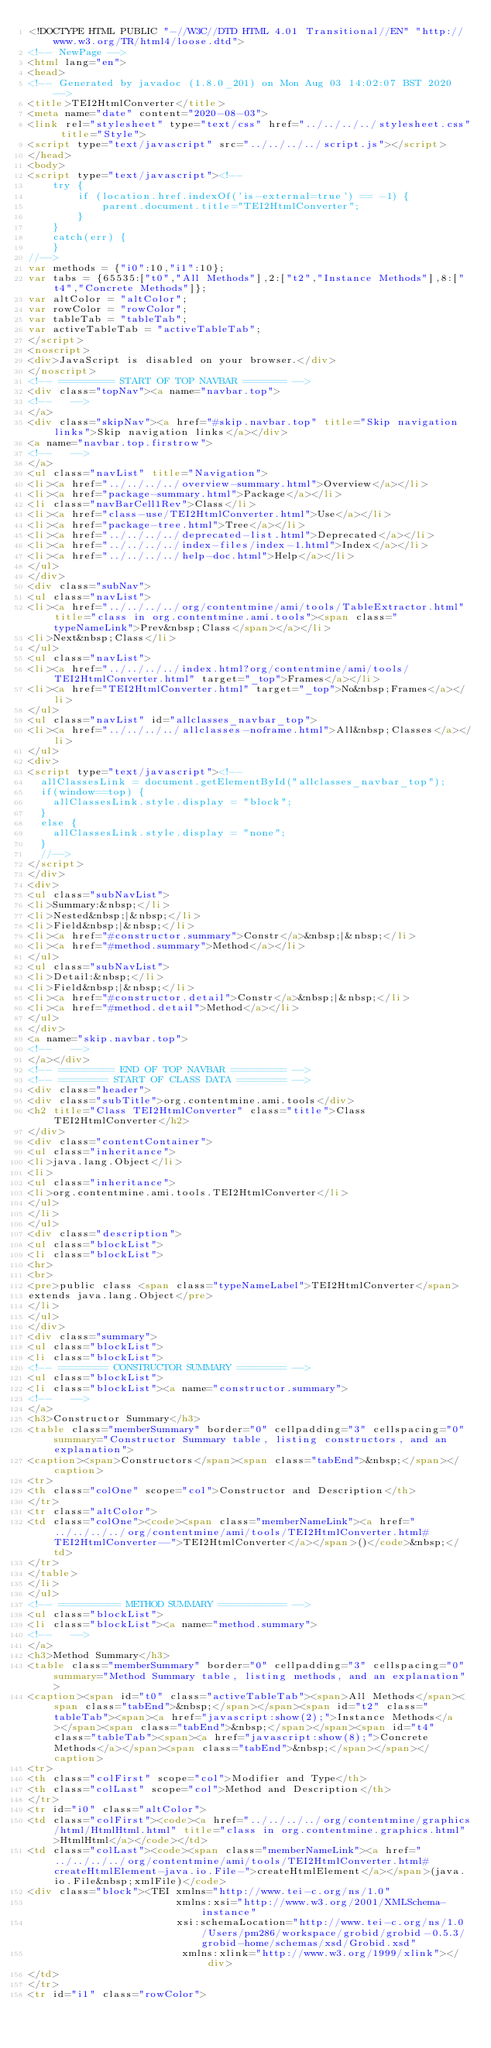<code> <loc_0><loc_0><loc_500><loc_500><_HTML_><!DOCTYPE HTML PUBLIC "-//W3C//DTD HTML 4.01 Transitional//EN" "http://www.w3.org/TR/html4/loose.dtd">
<!-- NewPage -->
<html lang="en">
<head>
<!-- Generated by javadoc (1.8.0_201) on Mon Aug 03 14:02:07 BST 2020 -->
<title>TEI2HtmlConverter</title>
<meta name="date" content="2020-08-03">
<link rel="stylesheet" type="text/css" href="../../../../stylesheet.css" title="Style">
<script type="text/javascript" src="../../../../script.js"></script>
</head>
<body>
<script type="text/javascript"><!--
    try {
        if (location.href.indexOf('is-external=true') == -1) {
            parent.document.title="TEI2HtmlConverter";
        }
    }
    catch(err) {
    }
//-->
var methods = {"i0":10,"i1":10};
var tabs = {65535:["t0","All Methods"],2:["t2","Instance Methods"],8:["t4","Concrete Methods"]};
var altColor = "altColor";
var rowColor = "rowColor";
var tableTab = "tableTab";
var activeTableTab = "activeTableTab";
</script>
<noscript>
<div>JavaScript is disabled on your browser.</div>
</noscript>
<!-- ========= START OF TOP NAVBAR ======= -->
<div class="topNav"><a name="navbar.top">
<!--   -->
</a>
<div class="skipNav"><a href="#skip.navbar.top" title="Skip navigation links">Skip navigation links</a></div>
<a name="navbar.top.firstrow">
<!--   -->
</a>
<ul class="navList" title="Navigation">
<li><a href="../../../../overview-summary.html">Overview</a></li>
<li><a href="package-summary.html">Package</a></li>
<li class="navBarCell1Rev">Class</li>
<li><a href="class-use/TEI2HtmlConverter.html">Use</a></li>
<li><a href="package-tree.html">Tree</a></li>
<li><a href="../../../../deprecated-list.html">Deprecated</a></li>
<li><a href="../../../../index-files/index-1.html">Index</a></li>
<li><a href="../../../../help-doc.html">Help</a></li>
</ul>
</div>
<div class="subNav">
<ul class="navList">
<li><a href="../../../../org/contentmine/ami/tools/TableExtractor.html" title="class in org.contentmine.ami.tools"><span class="typeNameLink">Prev&nbsp;Class</span></a></li>
<li>Next&nbsp;Class</li>
</ul>
<ul class="navList">
<li><a href="../../../../index.html?org/contentmine/ami/tools/TEI2HtmlConverter.html" target="_top">Frames</a></li>
<li><a href="TEI2HtmlConverter.html" target="_top">No&nbsp;Frames</a></li>
</ul>
<ul class="navList" id="allclasses_navbar_top">
<li><a href="../../../../allclasses-noframe.html">All&nbsp;Classes</a></li>
</ul>
<div>
<script type="text/javascript"><!--
  allClassesLink = document.getElementById("allclasses_navbar_top");
  if(window==top) {
    allClassesLink.style.display = "block";
  }
  else {
    allClassesLink.style.display = "none";
  }
  //-->
</script>
</div>
<div>
<ul class="subNavList">
<li>Summary:&nbsp;</li>
<li>Nested&nbsp;|&nbsp;</li>
<li>Field&nbsp;|&nbsp;</li>
<li><a href="#constructor.summary">Constr</a>&nbsp;|&nbsp;</li>
<li><a href="#method.summary">Method</a></li>
</ul>
<ul class="subNavList">
<li>Detail:&nbsp;</li>
<li>Field&nbsp;|&nbsp;</li>
<li><a href="#constructor.detail">Constr</a>&nbsp;|&nbsp;</li>
<li><a href="#method.detail">Method</a></li>
</ul>
</div>
<a name="skip.navbar.top">
<!--   -->
</a></div>
<!-- ========= END OF TOP NAVBAR ========= -->
<!-- ======== START OF CLASS DATA ======== -->
<div class="header">
<div class="subTitle">org.contentmine.ami.tools</div>
<h2 title="Class TEI2HtmlConverter" class="title">Class TEI2HtmlConverter</h2>
</div>
<div class="contentContainer">
<ul class="inheritance">
<li>java.lang.Object</li>
<li>
<ul class="inheritance">
<li>org.contentmine.ami.tools.TEI2HtmlConverter</li>
</ul>
</li>
</ul>
<div class="description">
<ul class="blockList">
<li class="blockList">
<hr>
<br>
<pre>public class <span class="typeNameLabel">TEI2HtmlConverter</span>
extends java.lang.Object</pre>
</li>
</ul>
</div>
<div class="summary">
<ul class="blockList">
<li class="blockList">
<!-- ======== CONSTRUCTOR SUMMARY ======== -->
<ul class="blockList">
<li class="blockList"><a name="constructor.summary">
<!--   -->
</a>
<h3>Constructor Summary</h3>
<table class="memberSummary" border="0" cellpadding="3" cellspacing="0" summary="Constructor Summary table, listing constructors, and an explanation">
<caption><span>Constructors</span><span class="tabEnd">&nbsp;</span></caption>
<tr>
<th class="colOne" scope="col">Constructor and Description</th>
</tr>
<tr class="altColor">
<td class="colOne"><code><span class="memberNameLink"><a href="../../../../org/contentmine/ami/tools/TEI2HtmlConverter.html#TEI2HtmlConverter--">TEI2HtmlConverter</a></span>()</code>&nbsp;</td>
</tr>
</table>
</li>
</ul>
<!-- ========== METHOD SUMMARY =========== -->
<ul class="blockList">
<li class="blockList"><a name="method.summary">
<!--   -->
</a>
<h3>Method Summary</h3>
<table class="memberSummary" border="0" cellpadding="3" cellspacing="0" summary="Method Summary table, listing methods, and an explanation">
<caption><span id="t0" class="activeTableTab"><span>All Methods</span><span class="tabEnd">&nbsp;</span></span><span id="t2" class="tableTab"><span><a href="javascript:show(2);">Instance Methods</a></span><span class="tabEnd">&nbsp;</span></span><span id="t4" class="tableTab"><span><a href="javascript:show(8);">Concrete Methods</a></span><span class="tabEnd">&nbsp;</span></span></caption>
<tr>
<th class="colFirst" scope="col">Modifier and Type</th>
<th class="colLast" scope="col">Method and Description</th>
</tr>
<tr id="i0" class="altColor">
<td class="colFirst"><code><a href="../../../../org/contentmine/graphics/html/HtmlHtml.html" title="class in org.contentmine.graphics.html">HtmlHtml</a></code></td>
<td class="colLast"><code><span class="memberNameLink"><a href="../../../../org/contentmine/ami/tools/TEI2HtmlConverter.html#createHtmlElement-java.io.File-">createHtmlElement</a></span>(java.io.File&nbsp;xmlFile)</code>
<div class="block"><TEI xmlns="http://www.tei-c.org/ns/1.0" 
                        xmlns:xsi="http://www.w3.org/2001/XMLSchema-instance" 
                        xsi:schemaLocation="http://www.tei-c.org/ns/1.0 /Users/pm286/workspace/grobid/grobid-0.5.3/grobid-home/schemas/xsd/Grobid.xsd"
                         xmlns:xlink="http://www.w3.org/1999/xlink"></div>
</td>
</tr>
<tr id="i1" class="rowColor"></code> 